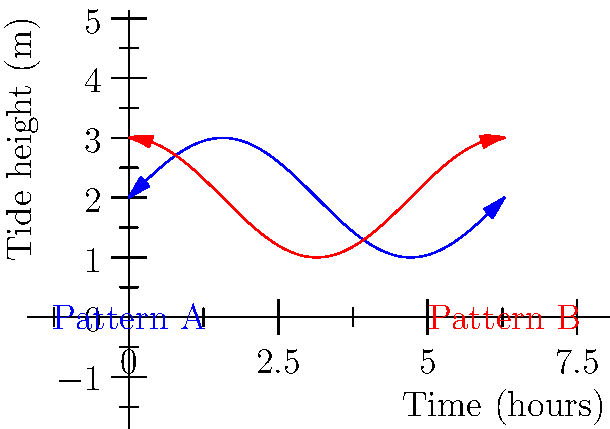The graph shows two tidal patterns observed in Lough Neagh over different 24-hour periods. As a local resident familiar with the lough's marine life, determine if these patterns are congruent and explain your reasoning. To determine if the tidal patterns are congruent, we need to follow these steps:

1. Examine the shape of both patterns:
   Both patterns appear to be sinusoidal, which is typical for tidal patterns.

2. Compare the amplitude:
   The amplitude (height) of both waves seems to be the same, approximately 1 meter from the midline.

3. Compare the period:
   Both patterns complete one full cycle in 24 hours (2π on the x-axis), so they have the same period.

4. Check for phase shift:
   Pattern B (red) appears to be shifted to the left by π/2 (quarter of a cycle or 6 hours) compared to Pattern A (blue).

5. Apply the definition of congruence:
   Two patterns are congruent if one can be transformed into the other through rigid transformations (translation, rotation, or reflection) without changing its size or shape.

6. Conclusion:
   Since the patterns have the same shape, amplitude, and period, and differ only by a phase shift (which is equivalent to a horizontal translation), they are indeed congruent.
Answer: Yes, congruent (phase shift of π/2) 